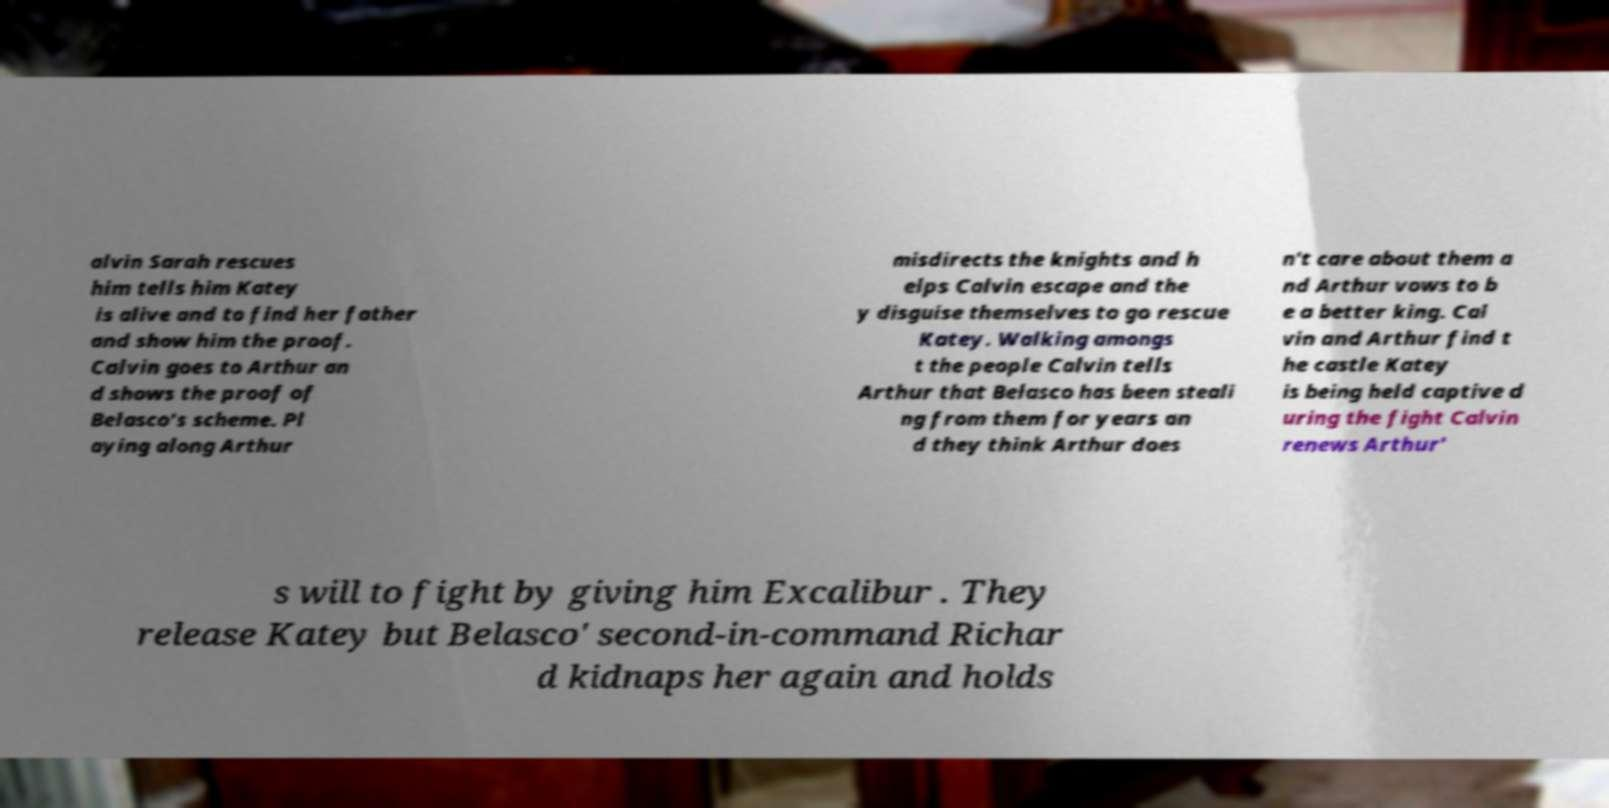Could you extract and type out the text from this image? alvin Sarah rescues him tells him Katey is alive and to find her father and show him the proof. Calvin goes to Arthur an d shows the proof of Belasco's scheme. Pl aying along Arthur misdirects the knights and h elps Calvin escape and the y disguise themselves to go rescue Katey. Walking amongs t the people Calvin tells Arthur that Belasco has been steali ng from them for years an d they think Arthur does n't care about them a nd Arthur vows to b e a better king. Cal vin and Arthur find t he castle Katey is being held captive d uring the fight Calvin renews Arthur' s will to fight by giving him Excalibur . They release Katey but Belasco' second-in-command Richar d kidnaps her again and holds 